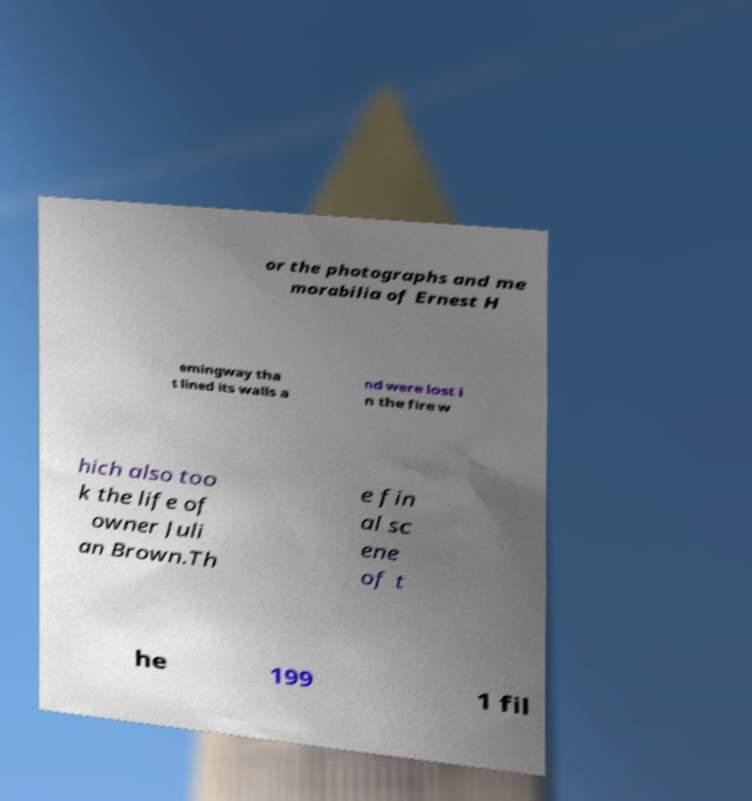Can you accurately transcribe the text from the provided image for me? or the photographs and me morabilia of Ernest H emingway tha t lined its walls a nd were lost i n the fire w hich also too k the life of owner Juli an Brown.Th e fin al sc ene of t he 199 1 fil 